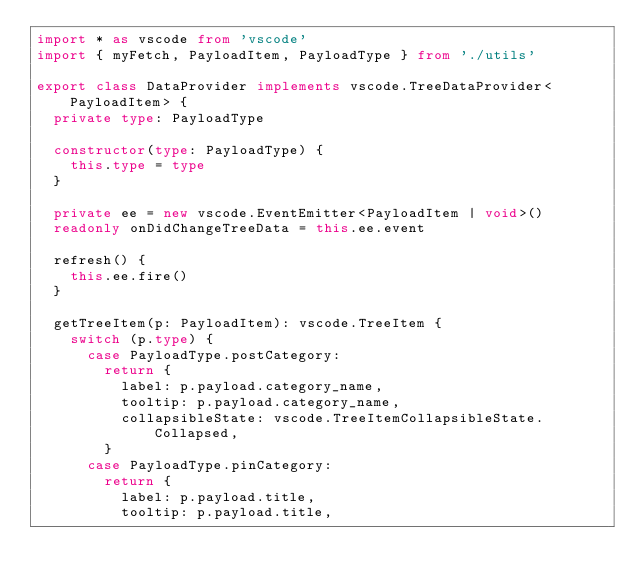Convert code to text. <code><loc_0><loc_0><loc_500><loc_500><_TypeScript_>import * as vscode from 'vscode'
import { myFetch, PayloadItem, PayloadType } from './utils'

export class DataProvider implements vscode.TreeDataProvider<PayloadItem> {
  private type: PayloadType

  constructor(type: PayloadType) {
    this.type = type
  }

  private ee = new vscode.EventEmitter<PayloadItem | void>()
  readonly onDidChangeTreeData = this.ee.event

  refresh() {
    this.ee.fire()
  }

  getTreeItem(p: PayloadItem): vscode.TreeItem {
    switch (p.type) {
      case PayloadType.postCategory:
        return {
          label: p.payload.category_name,
          tooltip: p.payload.category_name,
          collapsibleState: vscode.TreeItemCollapsibleState.Collapsed,
        }
      case PayloadType.pinCategory:
        return {
          label: p.payload.title,
          tooltip: p.payload.title,</code> 